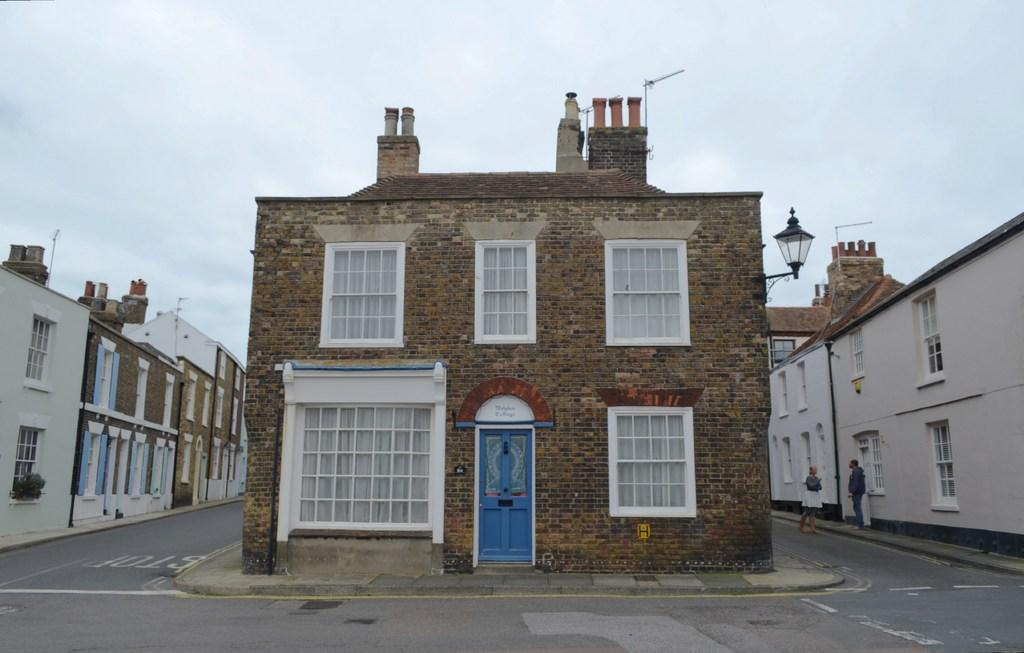How many buildings can be seen in the image? There are three different buildings in the image. What is the location of the buildings in relation to the road? The buildings are beside a road. Are there any people present near the buildings? Yes, there are two people standing beside one of the buildings. What force is being applied to the cent of the plot in the image? There is no force being applied to a cent or plot in the image, as the image features buildings and people beside a road. 